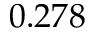<formula> <loc_0><loc_0><loc_500><loc_500>0 . 2 7 8</formula> 